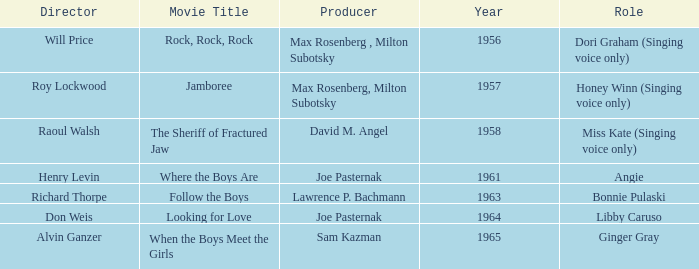What year was Jamboree made? 1957.0. 